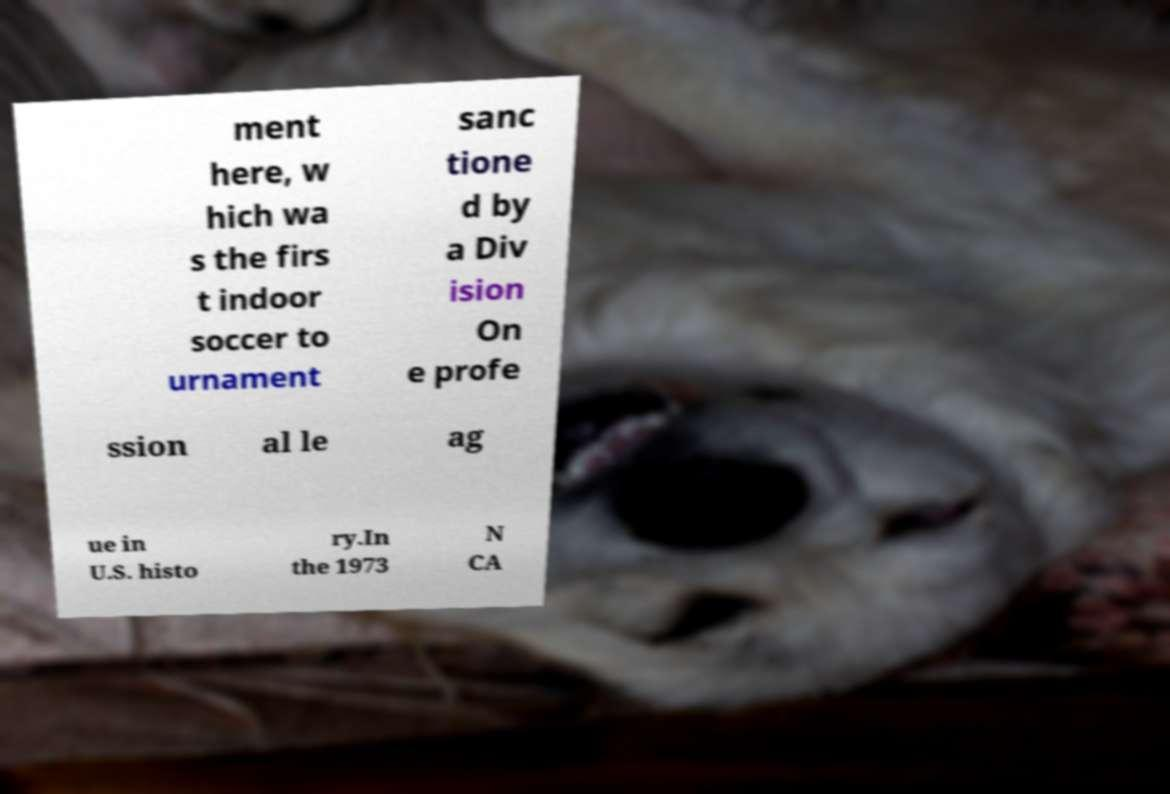Could you extract and type out the text from this image? ment here, w hich wa s the firs t indoor soccer to urnament sanc tione d by a Div ision On e profe ssion al le ag ue in U.S. histo ry.In the 1973 N CA 